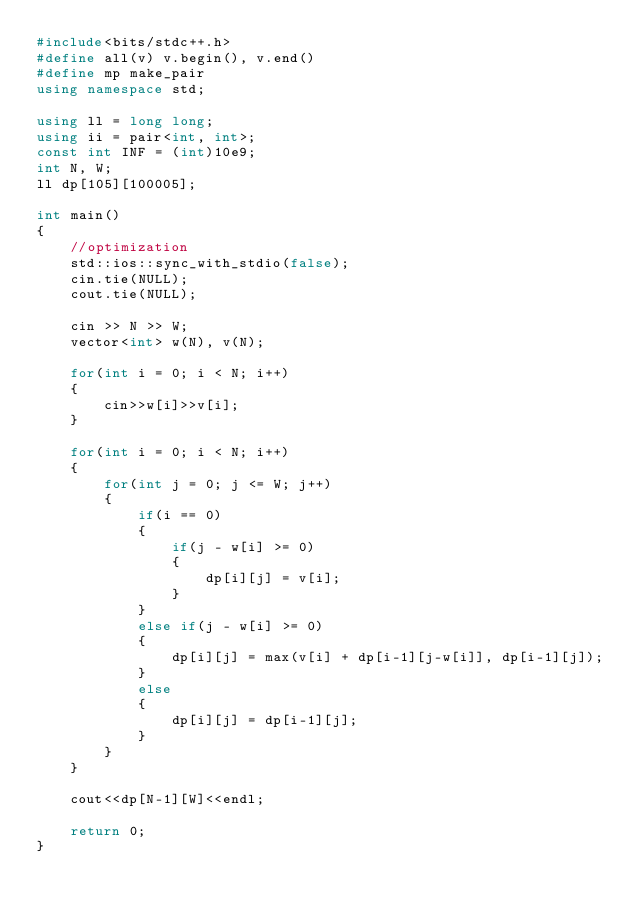Convert code to text. <code><loc_0><loc_0><loc_500><loc_500><_C++_>#include<bits/stdc++.h>
#define all(v) v.begin(), v.end()
#define mp make_pair
using namespace std;

using ll = long long;
using ii = pair<int, int>;
const int INF = (int)10e9;
int N, W;
ll dp[105][100005];

int main() 
{
    //optimization
    std::ios::sync_with_stdio(false);
    cin.tie(NULL);
    cout.tie(NULL);

    cin >> N >> W;
    vector<int> w(N), v(N);

    for(int i = 0; i < N; i++) 
    {
        cin>>w[i]>>v[i];
    }

    for(int i = 0; i < N; i++) 
    {
        for(int j = 0; j <= W; j++) 
        {
            if(i == 0) 
            { 
                if(j - w[i] >= 0) 
                {
                    dp[i][j] = v[i];
                }
            }
            else if(j - w[i] >= 0) 
            {
                dp[i][j] = max(v[i] + dp[i-1][j-w[i]], dp[i-1][j]);
            }
            else 
            {
                dp[i][j] = dp[i-1][j];
            }
        }
    }

    cout<<dp[N-1][W]<<endl;

    return 0;
}</code> 